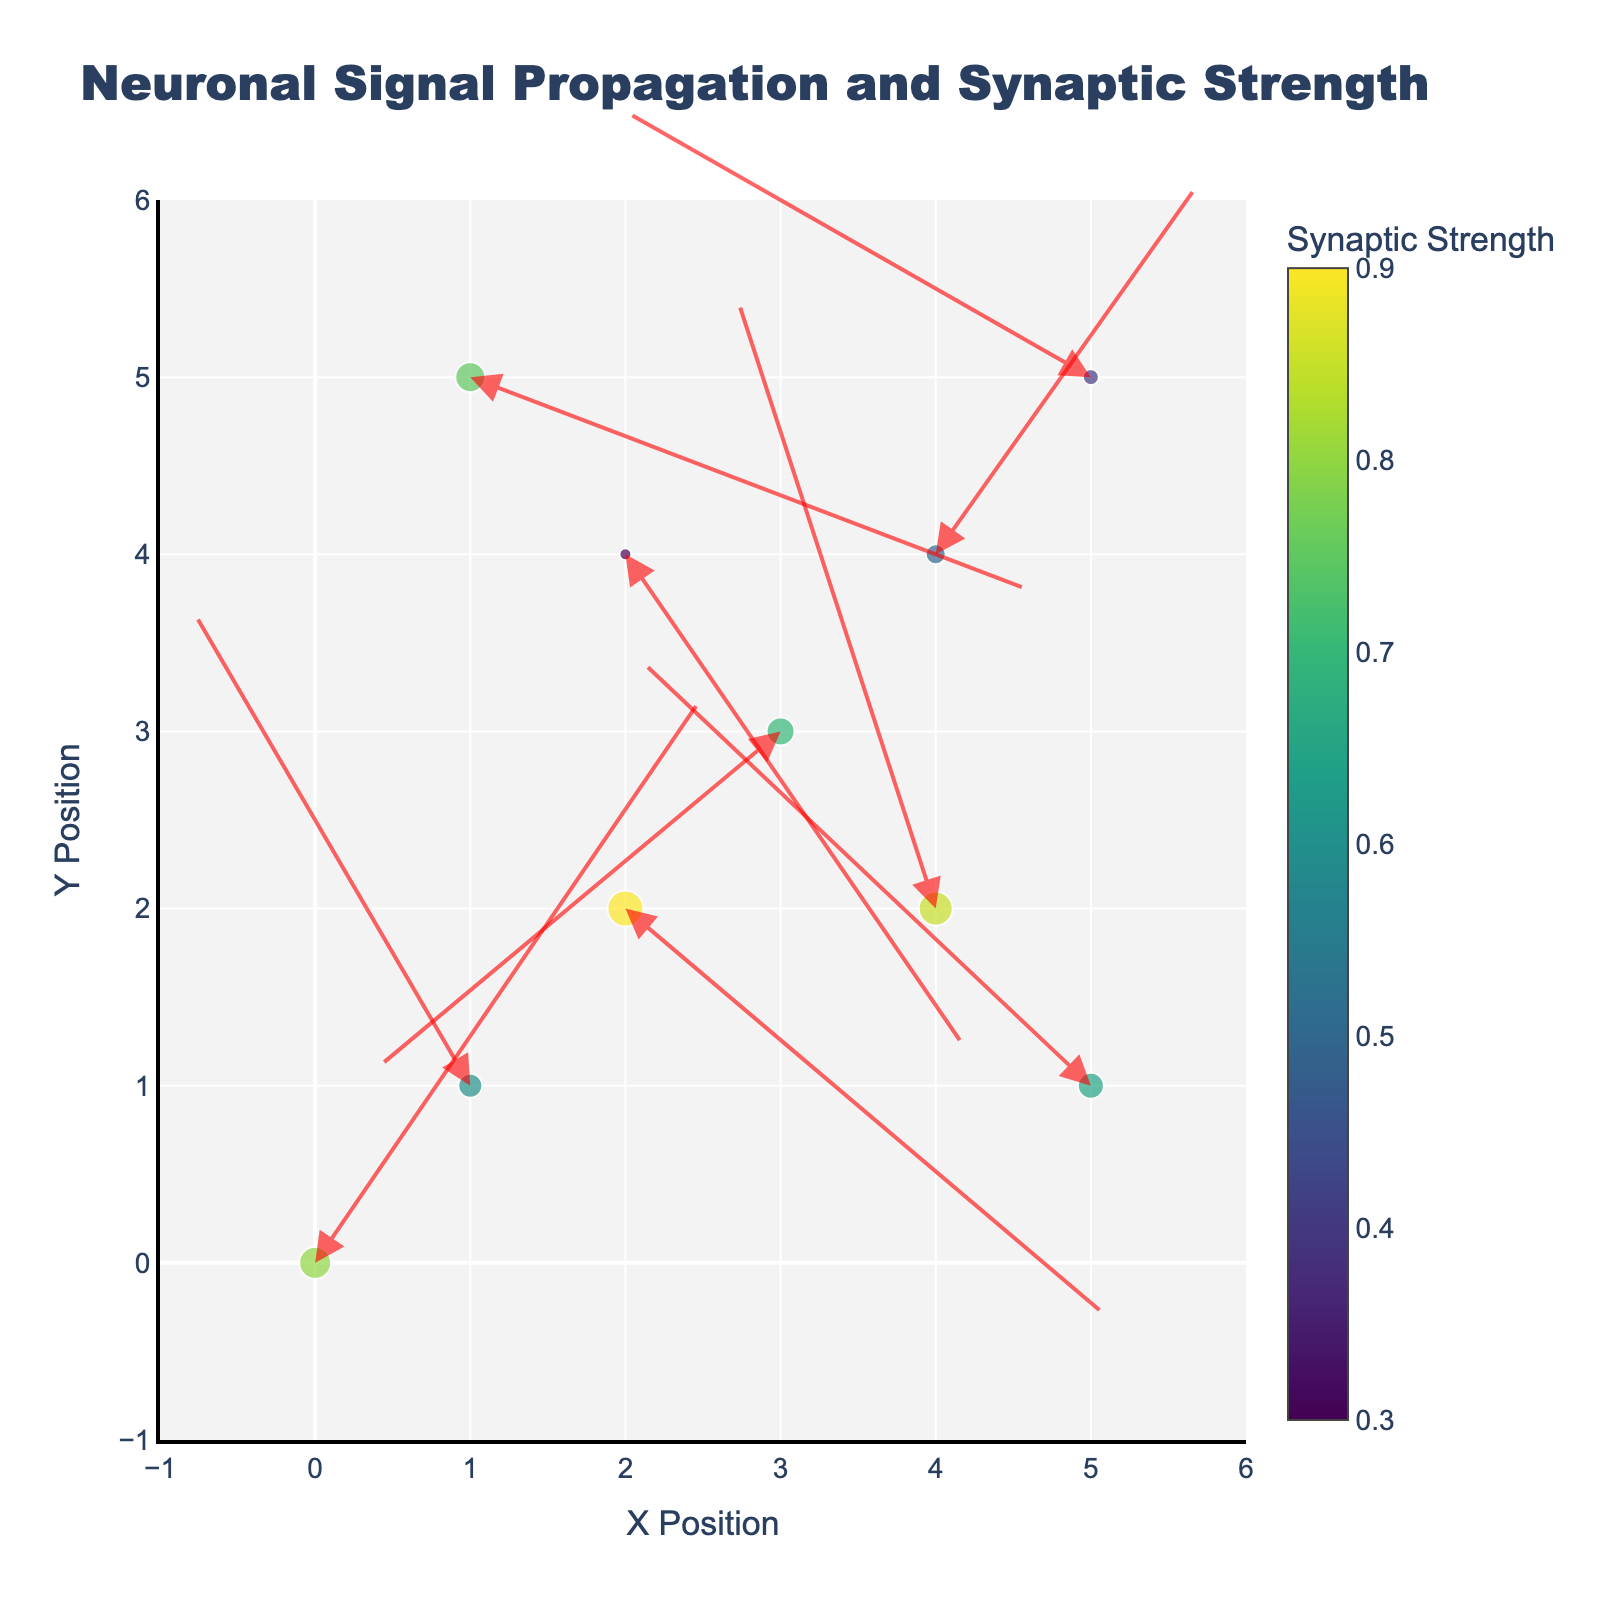What is the title of the plot? The title is usually displayed at the top of the plot. It summarizes the main topic or theme depicted in the visualization.
Answer: Neuronal Signal Propagation and Synaptic Strength What do the colors of the markers signify? The color of the markers is determined by the Synaptic Strength, which is indicated by the color scale on the right-hand side of the plot.
Answer: Synaptic Strength How many data points represent the neurotransmitter "GABA"? By examining the hover information or the labels indicating the neurotransmitters, we can count how many markers correspond to "GABA". There is one such data point.
Answer: 1 Which neurotransmitter is located at the coordinates (4, 4)? To find this, we look at the plot and hover over the marker at (4, 4) to see the neurotransmitter associated with these coordinates.
Answer: Acetylcholine Which data point has the highest synaptic strength? We can determine this by observing the size and color of the markers, with larger and darker markers indicating higher synaptic strength. The hover information can confirm the exact neurotransmitter.
Answer: NMDA What are the X and Y coordinates of the data point with the lowest synaptic strength? The data point with the smallest marker size and lightest color has the lowest synaptic strength. The corresponding X and Y coordinates can be noted from the plot.
Answer: (2, 4) Which two neurotransmitters show the largest difference in synaptic strength? We compare the synaptic strengths of all data points, identifying the two neurotransmitters with the maximum and minimum synaptic strengths and calculating their difference.
Answer: Glycine and Dopamine What direction and magnitude of the arrow can be seen at (1, 1)? By inspecting the arrow originating from (1, 1), we note its direction given by its components (U,V) and its length in terms of magnitude calculated as sqrt(U^2 + V^2).
Answer: Direction: (-1.8, 2.7); Magnitude: 3.24 